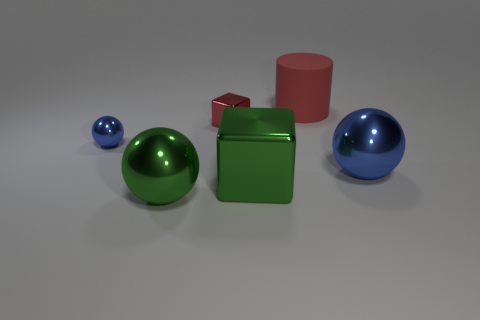Add 1 small cyan metal cylinders. How many objects exist? 7 Subtract all cylinders. How many objects are left? 5 Subtract 0 gray balls. How many objects are left? 6 Subtract all tiny blue metallic spheres. Subtract all green metallic cubes. How many objects are left? 4 Add 4 matte things. How many matte things are left? 5 Add 5 tiny green rubber spheres. How many tiny green rubber spheres exist? 5 